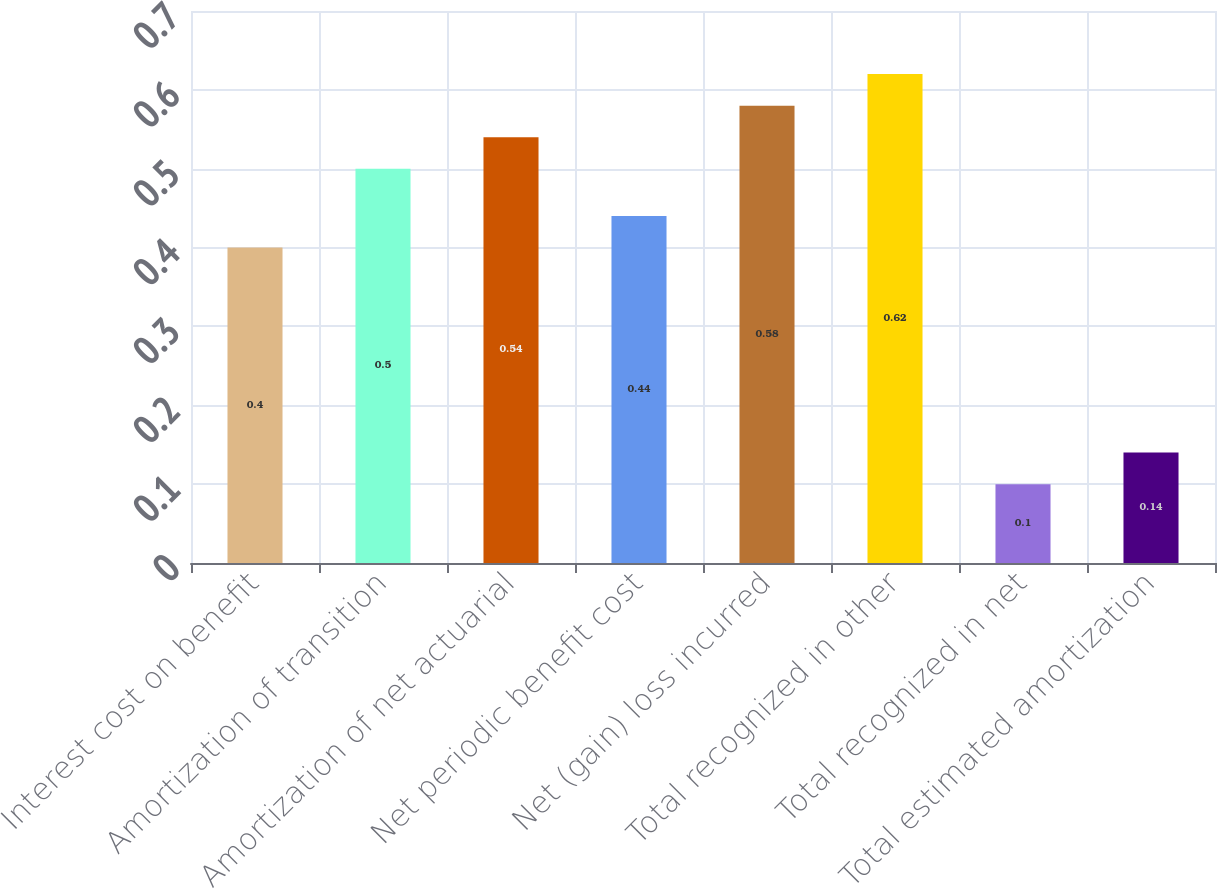Convert chart to OTSL. <chart><loc_0><loc_0><loc_500><loc_500><bar_chart><fcel>Interest cost on benefit<fcel>Amortization of transition<fcel>Amortization of net actuarial<fcel>Net periodic benefit cost<fcel>Net (gain) loss incurred<fcel>Total recognized in other<fcel>Total recognized in net<fcel>Total estimated amortization<nl><fcel>0.4<fcel>0.5<fcel>0.54<fcel>0.44<fcel>0.58<fcel>0.62<fcel>0.1<fcel>0.14<nl></chart> 